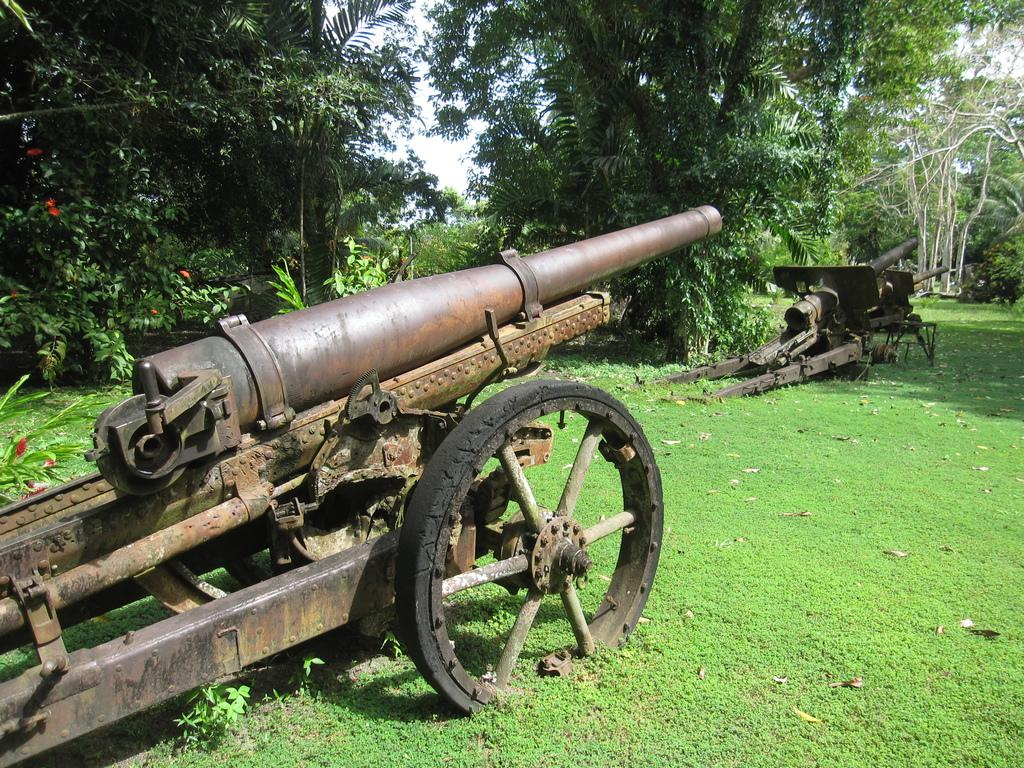What is the main setting of the image? The image shows an open grass ground. What objects can be seen on the grass ground? There are canons on the grass ground. What can be seen in the background of the image? There are trees in the background of the image. What else can be observed on the grass ground? Shadows are visible on the ground. What type of canvas is being used to paint the canons in the image? There is no canvas or painting activity present in the image; it shows actual canons on a grass ground. Can you describe the body language of the canons in the image? The canons are inanimate objects and do not have body language. 